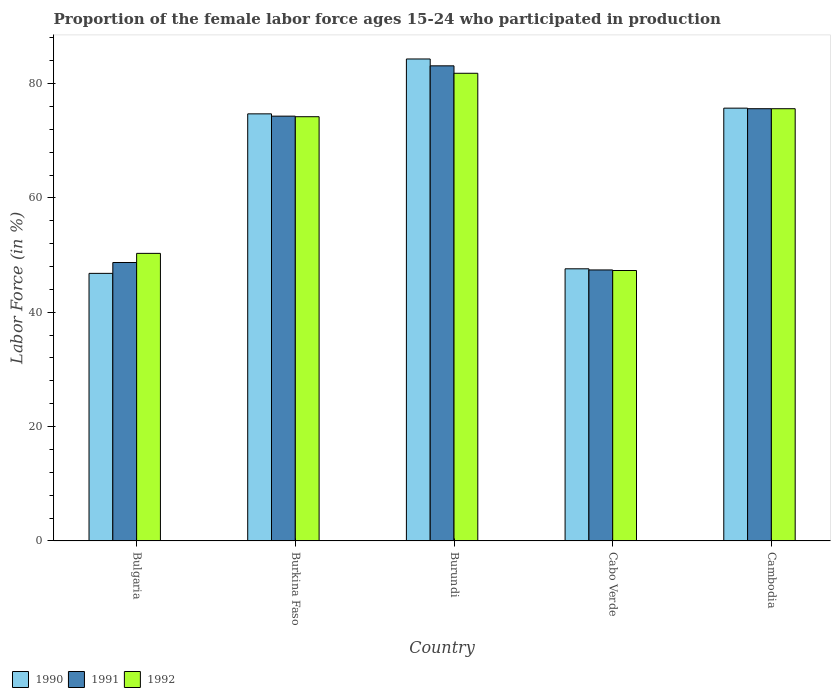How many different coloured bars are there?
Provide a succinct answer. 3. How many bars are there on the 5th tick from the left?
Your answer should be very brief. 3. What is the label of the 2nd group of bars from the left?
Make the answer very short. Burkina Faso. In how many cases, is the number of bars for a given country not equal to the number of legend labels?
Your answer should be very brief. 0. What is the proportion of the female labor force who participated in production in 1992 in Burkina Faso?
Keep it short and to the point. 74.2. Across all countries, what is the maximum proportion of the female labor force who participated in production in 1992?
Provide a succinct answer. 81.8. Across all countries, what is the minimum proportion of the female labor force who participated in production in 1991?
Your answer should be very brief. 47.4. In which country was the proportion of the female labor force who participated in production in 1990 maximum?
Make the answer very short. Burundi. In which country was the proportion of the female labor force who participated in production in 1990 minimum?
Keep it short and to the point. Bulgaria. What is the total proportion of the female labor force who participated in production in 1990 in the graph?
Make the answer very short. 329.1. What is the difference between the proportion of the female labor force who participated in production in 1991 in Bulgaria and that in Burundi?
Give a very brief answer. -34.4. What is the difference between the proportion of the female labor force who participated in production in 1992 in Burundi and the proportion of the female labor force who participated in production in 1991 in Cambodia?
Ensure brevity in your answer.  6.2. What is the average proportion of the female labor force who participated in production in 1991 per country?
Provide a short and direct response. 65.82. What is the difference between the proportion of the female labor force who participated in production of/in 1991 and proportion of the female labor force who participated in production of/in 1990 in Bulgaria?
Your response must be concise. 1.9. In how many countries, is the proportion of the female labor force who participated in production in 1992 greater than 4 %?
Ensure brevity in your answer.  5. What is the ratio of the proportion of the female labor force who participated in production in 1991 in Bulgaria to that in Burundi?
Keep it short and to the point. 0.59. Is the difference between the proportion of the female labor force who participated in production in 1991 in Bulgaria and Cambodia greater than the difference between the proportion of the female labor force who participated in production in 1990 in Bulgaria and Cambodia?
Offer a very short reply. Yes. What is the difference between the highest and the lowest proportion of the female labor force who participated in production in 1992?
Your response must be concise. 34.5. In how many countries, is the proportion of the female labor force who participated in production in 1990 greater than the average proportion of the female labor force who participated in production in 1990 taken over all countries?
Keep it short and to the point. 3. What does the 2nd bar from the left in Cabo Verde represents?
Offer a very short reply. 1991. What does the 1st bar from the right in Cambodia represents?
Keep it short and to the point. 1992. Are all the bars in the graph horizontal?
Keep it short and to the point. No. Does the graph contain any zero values?
Give a very brief answer. No. How many legend labels are there?
Give a very brief answer. 3. What is the title of the graph?
Keep it short and to the point. Proportion of the female labor force ages 15-24 who participated in production. What is the label or title of the Y-axis?
Ensure brevity in your answer.  Labor Force (in %). What is the Labor Force (in %) in 1990 in Bulgaria?
Your answer should be compact. 46.8. What is the Labor Force (in %) in 1991 in Bulgaria?
Give a very brief answer. 48.7. What is the Labor Force (in %) in 1992 in Bulgaria?
Your answer should be compact. 50.3. What is the Labor Force (in %) in 1990 in Burkina Faso?
Your answer should be very brief. 74.7. What is the Labor Force (in %) in 1991 in Burkina Faso?
Offer a terse response. 74.3. What is the Labor Force (in %) of 1992 in Burkina Faso?
Your response must be concise. 74.2. What is the Labor Force (in %) of 1990 in Burundi?
Give a very brief answer. 84.3. What is the Labor Force (in %) in 1991 in Burundi?
Make the answer very short. 83.1. What is the Labor Force (in %) of 1992 in Burundi?
Keep it short and to the point. 81.8. What is the Labor Force (in %) in 1990 in Cabo Verde?
Keep it short and to the point. 47.6. What is the Labor Force (in %) in 1991 in Cabo Verde?
Provide a short and direct response. 47.4. What is the Labor Force (in %) of 1992 in Cabo Verde?
Provide a short and direct response. 47.3. What is the Labor Force (in %) in 1990 in Cambodia?
Offer a very short reply. 75.7. What is the Labor Force (in %) of 1991 in Cambodia?
Provide a short and direct response. 75.6. What is the Labor Force (in %) in 1992 in Cambodia?
Ensure brevity in your answer.  75.6. Across all countries, what is the maximum Labor Force (in %) of 1990?
Provide a succinct answer. 84.3. Across all countries, what is the maximum Labor Force (in %) in 1991?
Keep it short and to the point. 83.1. Across all countries, what is the maximum Labor Force (in %) in 1992?
Provide a succinct answer. 81.8. Across all countries, what is the minimum Labor Force (in %) of 1990?
Your response must be concise. 46.8. Across all countries, what is the minimum Labor Force (in %) of 1991?
Your answer should be compact. 47.4. Across all countries, what is the minimum Labor Force (in %) of 1992?
Make the answer very short. 47.3. What is the total Labor Force (in %) in 1990 in the graph?
Ensure brevity in your answer.  329.1. What is the total Labor Force (in %) in 1991 in the graph?
Provide a succinct answer. 329.1. What is the total Labor Force (in %) in 1992 in the graph?
Your response must be concise. 329.2. What is the difference between the Labor Force (in %) of 1990 in Bulgaria and that in Burkina Faso?
Ensure brevity in your answer.  -27.9. What is the difference between the Labor Force (in %) of 1991 in Bulgaria and that in Burkina Faso?
Your answer should be compact. -25.6. What is the difference between the Labor Force (in %) of 1992 in Bulgaria and that in Burkina Faso?
Make the answer very short. -23.9. What is the difference between the Labor Force (in %) of 1990 in Bulgaria and that in Burundi?
Ensure brevity in your answer.  -37.5. What is the difference between the Labor Force (in %) in 1991 in Bulgaria and that in Burundi?
Your response must be concise. -34.4. What is the difference between the Labor Force (in %) of 1992 in Bulgaria and that in Burundi?
Your answer should be very brief. -31.5. What is the difference between the Labor Force (in %) of 1991 in Bulgaria and that in Cabo Verde?
Your answer should be compact. 1.3. What is the difference between the Labor Force (in %) of 1992 in Bulgaria and that in Cabo Verde?
Offer a very short reply. 3. What is the difference between the Labor Force (in %) of 1990 in Bulgaria and that in Cambodia?
Your answer should be compact. -28.9. What is the difference between the Labor Force (in %) in 1991 in Bulgaria and that in Cambodia?
Your answer should be very brief. -26.9. What is the difference between the Labor Force (in %) in 1992 in Bulgaria and that in Cambodia?
Give a very brief answer. -25.3. What is the difference between the Labor Force (in %) of 1990 in Burkina Faso and that in Burundi?
Keep it short and to the point. -9.6. What is the difference between the Labor Force (in %) of 1991 in Burkina Faso and that in Burundi?
Offer a very short reply. -8.8. What is the difference between the Labor Force (in %) of 1992 in Burkina Faso and that in Burundi?
Keep it short and to the point. -7.6. What is the difference between the Labor Force (in %) of 1990 in Burkina Faso and that in Cabo Verde?
Your response must be concise. 27.1. What is the difference between the Labor Force (in %) of 1991 in Burkina Faso and that in Cabo Verde?
Your response must be concise. 26.9. What is the difference between the Labor Force (in %) in 1992 in Burkina Faso and that in Cabo Verde?
Offer a terse response. 26.9. What is the difference between the Labor Force (in %) of 1990 in Burkina Faso and that in Cambodia?
Make the answer very short. -1. What is the difference between the Labor Force (in %) of 1990 in Burundi and that in Cabo Verde?
Provide a succinct answer. 36.7. What is the difference between the Labor Force (in %) in 1991 in Burundi and that in Cabo Verde?
Your answer should be very brief. 35.7. What is the difference between the Labor Force (in %) in 1992 in Burundi and that in Cabo Verde?
Keep it short and to the point. 34.5. What is the difference between the Labor Force (in %) of 1990 in Burundi and that in Cambodia?
Offer a terse response. 8.6. What is the difference between the Labor Force (in %) in 1991 in Burundi and that in Cambodia?
Make the answer very short. 7.5. What is the difference between the Labor Force (in %) in 1990 in Cabo Verde and that in Cambodia?
Your response must be concise. -28.1. What is the difference between the Labor Force (in %) of 1991 in Cabo Verde and that in Cambodia?
Your answer should be very brief. -28.2. What is the difference between the Labor Force (in %) in 1992 in Cabo Verde and that in Cambodia?
Keep it short and to the point. -28.3. What is the difference between the Labor Force (in %) of 1990 in Bulgaria and the Labor Force (in %) of 1991 in Burkina Faso?
Ensure brevity in your answer.  -27.5. What is the difference between the Labor Force (in %) of 1990 in Bulgaria and the Labor Force (in %) of 1992 in Burkina Faso?
Your response must be concise. -27.4. What is the difference between the Labor Force (in %) in 1991 in Bulgaria and the Labor Force (in %) in 1992 in Burkina Faso?
Your answer should be compact. -25.5. What is the difference between the Labor Force (in %) of 1990 in Bulgaria and the Labor Force (in %) of 1991 in Burundi?
Offer a very short reply. -36.3. What is the difference between the Labor Force (in %) of 1990 in Bulgaria and the Labor Force (in %) of 1992 in Burundi?
Ensure brevity in your answer.  -35. What is the difference between the Labor Force (in %) in 1991 in Bulgaria and the Labor Force (in %) in 1992 in Burundi?
Your response must be concise. -33.1. What is the difference between the Labor Force (in %) in 1990 in Bulgaria and the Labor Force (in %) in 1991 in Cabo Verde?
Provide a short and direct response. -0.6. What is the difference between the Labor Force (in %) in 1990 in Bulgaria and the Labor Force (in %) in 1992 in Cabo Verde?
Your answer should be very brief. -0.5. What is the difference between the Labor Force (in %) in 1990 in Bulgaria and the Labor Force (in %) in 1991 in Cambodia?
Keep it short and to the point. -28.8. What is the difference between the Labor Force (in %) in 1990 in Bulgaria and the Labor Force (in %) in 1992 in Cambodia?
Your answer should be very brief. -28.8. What is the difference between the Labor Force (in %) of 1991 in Bulgaria and the Labor Force (in %) of 1992 in Cambodia?
Provide a succinct answer. -26.9. What is the difference between the Labor Force (in %) of 1990 in Burkina Faso and the Labor Force (in %) of 1991 in Burundi?
Give a very brief answer. -8.4. What is the difference between the Labor Force (in %) in 1990 in Burkina Faso and the Labor Force (in %) in 1991 in Cabo Verde?
Provide a succinct answer. 27.3. What is the difference between the Labor Force (in %) in 1990 in Burkina Faso and the Labor Force (in %) in 1992 in Cabo Verde?
Your answer should be compact. 27.4. What is the difference between the Labor Force (in %) of 1991 in Burkina Faso and the Labor Force (in %) of 1992 in Cambodia?
Provide a short and direct response. -1.3. What is the difference between the Labor Force (in %) of 1990 in Burundi and the Labor Force (in %) of 1991 in Cabo Verde?
Your answer should be compact. 36.9. What is the difference between the Labor Force (in %) of 1991 in Burundi and the Labor Force (in %) of 1992 in Cabo Verde?
Provide a short and direct response. 35.8. What is the difference between the Labor Force (in %) of 1990 in Burundi and the Labor Force (in %) of 1991 in Cambodia?
Make the answer very short. 8.7. What is the difference between the Labor Force (in %) of 1990 in Burundi and the Labor Force (in %) of 1992 in Cambodia?
Offer a very short reply. 8.7. What is the difference between the Labor Force (in %) of 1991 in Burundi and the Labor Force (in %) of 1992 in Cambodia?
Provide a succinct answer. 7.5. What is the difference between the Labor Force (in %) in 1990 in Cabo Verde and the Labor Force (in %) in 1992 in Cambodia?
Offer a terse response. -28. What is the difference between the Labor Force (in %) of 1991 in Cabo Verde and the Labor Force (in %) of 1992 in Cambodia?
Offer a terse response. -28.2. What is the average Labor Force (in %) of 1990 per country?
Your answer should be very brief. 65.82. What is the average Labor Force (in %) of 1991 per country?
Provide a succinct answer. 65.82. What is the average Labor Force (in %) of 1992 per country?
Your answer should be compact. 65.84. What is the difference between the Labor Force (in %) in 1990 and Labor Force (in %) in 1991 in Bulgaria?
Offer a terse response. -1.9. What is the difference between the Labor Force (in %) of 1990 and Labor Force (in %) of 1991 in Burkina Faso?
Your answer should be very brief. 0.4. What is the difference between the Labor Force (in %) in 1990 and Labor Force (in %) in 1991 in Cabo Verde?
Offer a very short reply. 0.2. What is the ratio of the Labor Force (in %) of 1990 in Bulgaria to that in Burkina Faso?
Provide a short and direct response. 0.63. What is the ratio of the Labor Force (in %) in 1991 in Bulgaria to that in Burkina Faso?
Your response must be concise. 0.66. What is the ratio of the Labor Force (in %) of 1992 in Bulgaria to that in Burkina Faso?
Ensure brevity in your answer.  0.68. What is the ratio of the Labor Force (in %) of 1990 in Bulgaria to that in Burundi?
Provide a succinct answer. 0.56. What is the ratio of the Labor Force (in %) in 1991 in Bulgaria to that in Burundi?
Offer a terse response. 0.59. What is the ratio of the Labor Force (in %) of 1992 in Bulgaria to that in Burundi?
Your answer should be compact. 0.61. What is the ratio of the Labor Force (in %) of 1990 in Bulgaria to that in Cabo Verde?
Give a very brief answer. 0.98. What is the ratio of the Labor Force (in %) of 1991 in Bulgaria to that in Cabo Verde?
Your answer should be very brief. 1.03. What is the ratio of the Labor Force (in %) of 1992 in Bulgaria to that in Cabo Verde?
Provide a succinct answer. 1.06. What is the ratio of the Labor Force (in %) in 1990 in Bulgaria to that in Cambodia?
Your response must be concise. 0.62. What is the ratio of the Labor Force (in %) of 1991 in Bulgaria to that in Cambodia?
Your response must be concise. 0.64. What is the ratio of the Labor Force (in %) in 1992 in Bulgaria to that in Cambodia?
Provide a succinct answer. 0.67. What is the ratio of the Labor Force (in %) in 1990 in Burkina Faso to that in Burundi?
Provide a succinct answer. 0.89. What is the ratio of the Labor Force (in %) of 1991 in Burkina Faso to that in Burundi?
Your response must be concise. 0.89. What is the ratio of the Labor Force (in %) in 1992 in Burkina Faso to that in Burundi?
Offer a very short reply. 0.91. What is the ratio of the Labor Force (in %) in 1990 in Burkina Faso to that in Cabo Verde?
Your answer should be compact. 1.57. What is the ratio of the Labor Force (in %) of 1991 in Burkina Faso to that in Cabo Verde?
Provide a succinct answer. 1.57. What is the ratio of the Labor Force (in %) of 1992 in Burkina Faso to that in Cabo Verde?
Your answer should be compact. 1.57. What is the ratio of the Labor Force (in %) in 1990 in Burkina Faso to that in Cambodia?
Your response must be concise. 0.99. What is the ratio of the Labor Force (in %) in 1991 in Burkina Faso to that in Cambodia?
Your response must be concise. 0.98. What is the ratio of the Labor Force (in %) of 1992 in Burkina Faso to that in Cambodia?
Give a very brief answer. 0.98. What is the ratio of the Labor Force (in %) in 1990 in Burundi to that in Cabo Verde?
Ensure brevity in your answer.  1.77. What is the ratio of the Labor Force (in %) of 1991 in Burundi to that in Cabo Verde?
Keep it short and to the point. 1.75. What is the ratio of the Labor Force (in %) of 1992 in Burundi to that in Cabo Verde?
Your answer should be very brief. 1.73. What is the ratio of the Labor Force (in %) in 1990 in Burundi to that in Cambodia?
Provide a succinct answer. 1.11. What is the ratio of the Labor Force (in %) of 1991 in Burundi to that in Cambodia?
Make the answer very short. 1.1. What is the ratio of the Labor Force (in %) of 1992 in Burundi to that in Cambodia?
Provide a short and direct response. 1.08. What is the ratio of the Labor Force (in %) in 1990 in Cabo Verde to that in Cambodia?
Give a very brief answer. 0.63. What is the ratio of the Labor Force (in %) in 1991 in Cabo Verde to that in Cambodia?
Provide a succinct answer. 0.63. What is the ratio of the Labor Force (in %) of 1992 in Cabo Verde to that in Cambodia?
Provide a succinct answer. 0.63. What is the difference between the highest and the lowest Labor Force (in %) of 1990?
Offer a very short reply. 37.5. What is the difference between the highest and the lowest Labor Force (in %) of 1991?
Provide a succinct answer. 35.7. What is the difference between the highest and the lowest Labor Force (in %) in 1992?
Offer a very short reply. 34.5. 